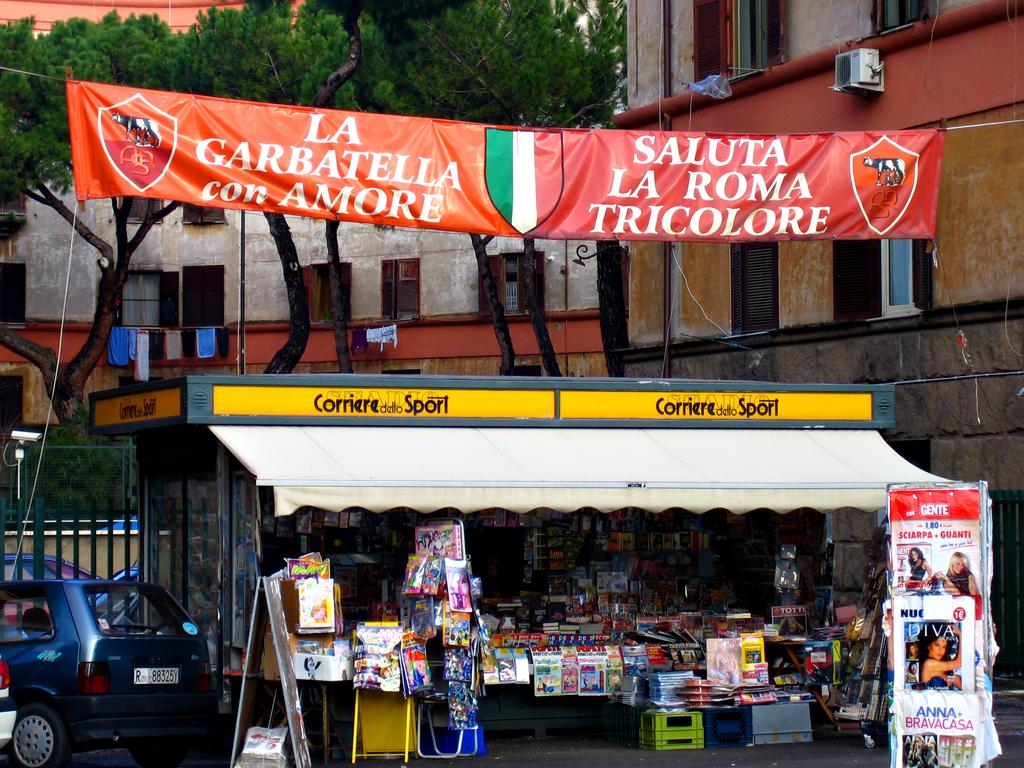What type of structures can be seen in the image? There are buildings in the image. What natural elements are present in the image? There are trees in the image. What type of barrier can be seen in the image? There is a fence in the image. What type of transportation is visible in the image? There are vehicles in the image. What type of signage is present in the image? There is a banner with text and a shop with text in the image. What type of oven can be seen in the image? There is no oven present in the image. What type of lace is used to decorate the banner in the image? There is no lace present in the image; the banner has text but no lace. 